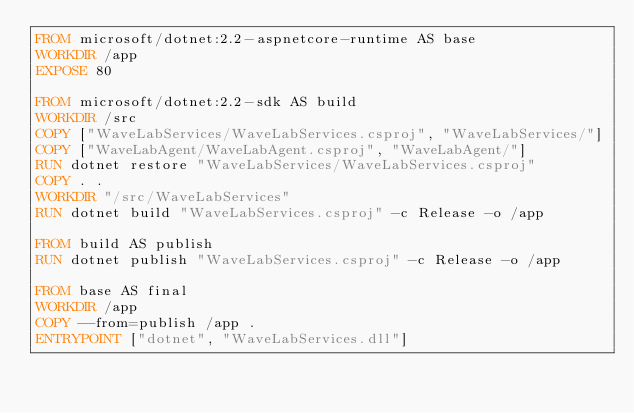Convert code to text. <code><loc_0><loc_0><loc_500><loc_500><_Dockerfile_>FROM microsoft/dotnet:2.2-aspnetcore-runtime AS base
WORKDIR /app
EXPOSE 80

FROM microsoft/dotnet:2.2-sdk AS build
WORKDIR /src
COPY ["WaveLabServices/WaveLabServices.csproj", "WaveLabServices/"]
COPY ["WaveLabAgent/WaveLabAgent.csproj", "WaveLabAgent/"]
RUN dotnet restore "WaveLabServices/WaveLabServices.csproj"
COPY . .
WORKDIR "/src/WaveLabServices"
RUN dotnet build "WaveLabServices.csproj" -c Release -o /app

FROM build AS publish
RUN dotnet publish "WaveLabServices.csproj" -c Release -o /app

FROM base AS final
WORKDIR /app
COPY --from=publish /app .
ENTRYPOINT ["dotnet", "WaveLabServices.dll"]</code> 